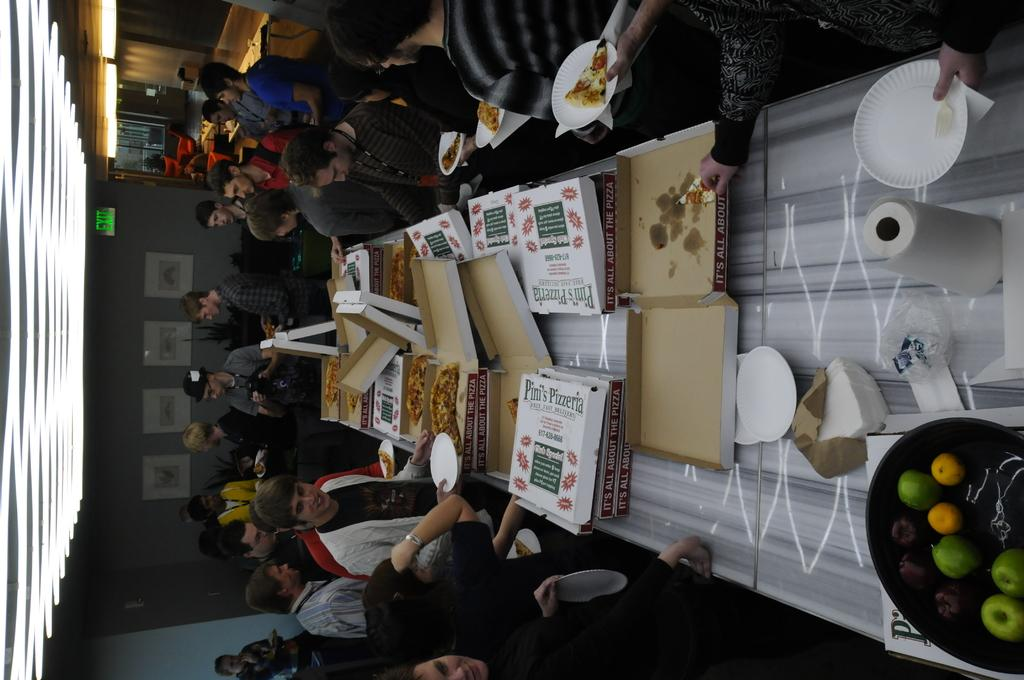What type of furniture is located on the right side of the image? There is a dining table on the right side of the image. What is on the dining table? There are pizzas on the dining table. Where are the people in the image? The people are on the left side of the image. Can you see any ghosts joining the people for dinner in the image? There are no ghosts present in the image, and therefore no ghosts can be seen joining the people for dinner. 